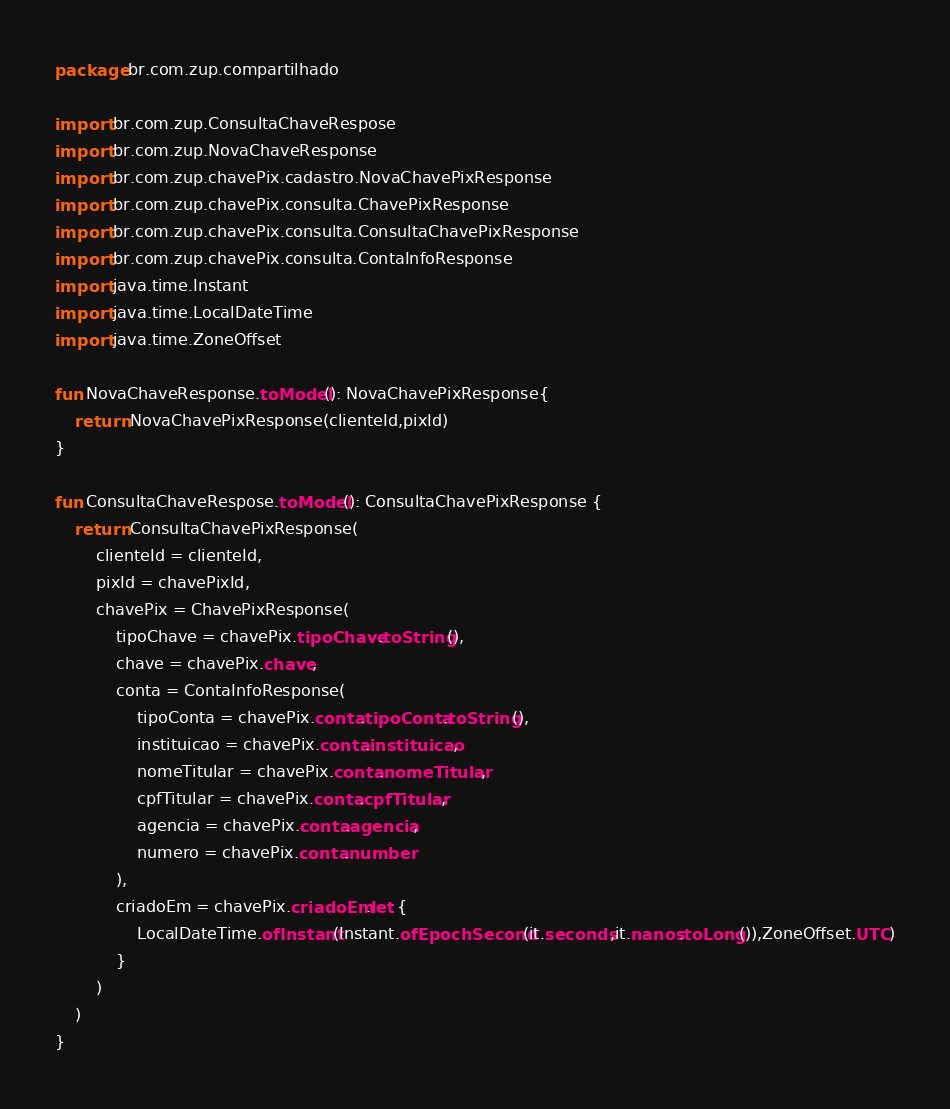Convert code to text. <code><loc_0><loc_0><loc_500><loc_500><_Kotlin_>package br.com.zup.compartilhado

import br.com.zup.ConsultaChaveRespose
import br.com.zup.NovaChaveResponse
import br.com.zup.chavePix.cadastro.NovaChavePixResponse
import br.com.zup.chavePix.consulta.ChavePixResponse
import br.com.zup.chavePix.consulta.ConsultaChavePixResponse
import br.com.zup.chavePix.consulta.ContaInfoResponse
import java.time.Instant
import java.time.LocalDateTime
import java.time.ZoneOffset

fun NovaChaveResponse.toModel(): NovaChavePixResponse{
    return NovaChavePixResponse(clienteId,pixId)
}

fun ConsultaChaveRespose.toModel(): ConsultaChavePixResponse {
    return ConsultaChavePixResponse(
        clienteId = clienteId,
        pixId = chavePixId,
        chavePix = ChavePixResponse(
            tipoChave = chavePix.tipoChave.toString(),
            chave = chavePix.chave,
            conta = ContaInfoResponse(
                tipoConta = chavePix.conta.tipoConta.toString(),
                instituicao = chavePix.conta.instituicao,
                nomeTitular = chavePix.conta.nomeTitular,
                cpfTitular = chavePix.conta.cpfTitular,
                agencia = chavePix.conta.agencia,
                numero = chavePix.conta.number
            ),
            criadoEm = chavePix.criadoEm.let {
                LocalDateTime.ofInstant(Instant.ofEpochSecond(it.seconds,it.nanos.toLong()),ZoneOffset.UTC)
            }
        )
    )
}</code> 